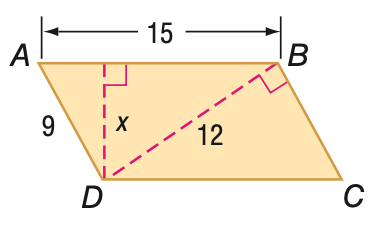Answer the mathemtical geometry problem and directly provide the correct option letter.
Question: Find x in parallelogram A B C D.
Choices: A: 5 B: 6 C: 7.2 D: 8.1 C 